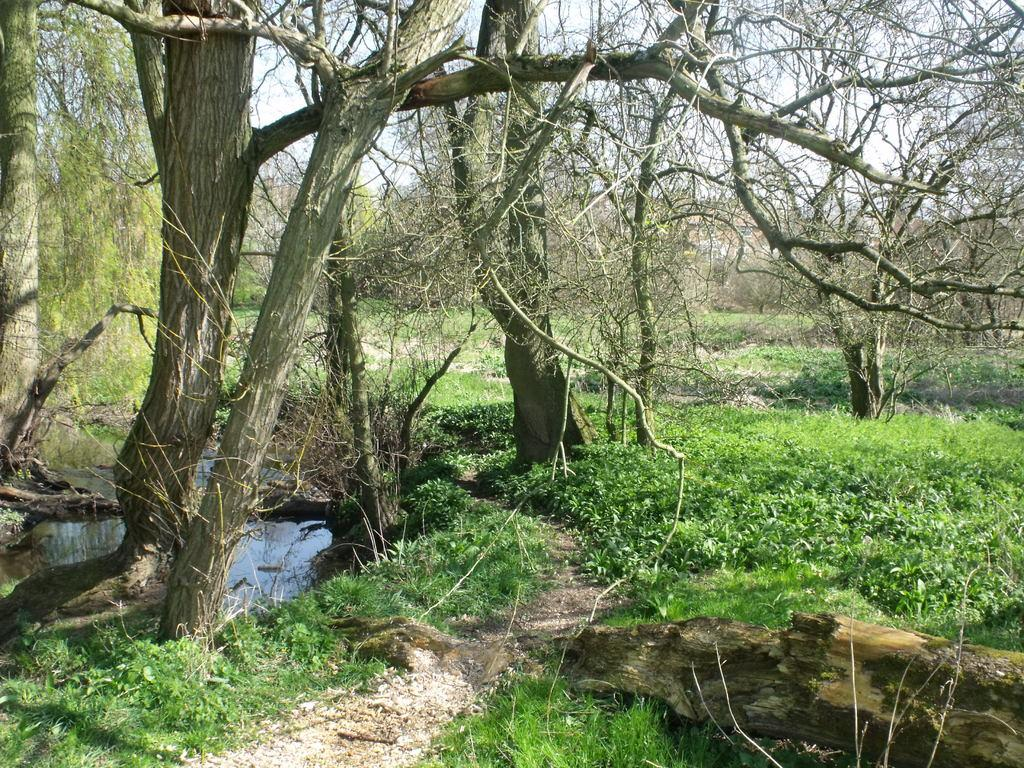What can be seen in the sky in the image? The sky is visible in the image, and there are clouds in the sky. What type of vegetation is present in the image? There are trees in the image, and creepers are also present. What body of water can be seen in the image? There is a pond in the image. What is visible on the ground in the image? The ground is visible in the image, and there are logs present. What type of grape is being used to exercise authority in the image? There is no grape present in the image, and no authority is being exercised. 